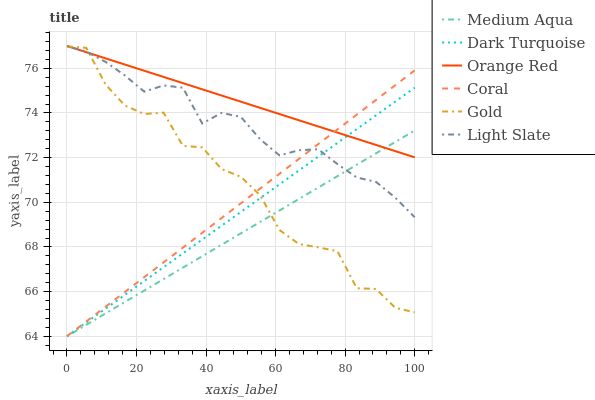Does Medium Aqua have the minimum area under the curve?
Answer yes or no. Yes. Does Orange Red have the maximum area under the curve?
Answer yes or no. Yes. Does Light Slate have the minimum area under the curve?
Answer yes or no. No. Does Light Slate have the maximum area under the curve?
Answer yes or no. No. Is Orange Red the smoothest?
Answer yes or no. Yes. Is Gold the roughest?
Answer yes or no. Yes. Is Light Slate the smoothest?
Answer yes or no. No. Is Light Slate the roughest?
Answer yes or no. No. Does Dark Turquoise have the lowest value?
Answer yes or no. Yes. Does Light Slate have the lowest value?
Answer yes or no. No. Does Orange Red have the highest value?
Answer yes or no. Yes. Does Dark Turquoise have the highest value?
Answer yes or no. No. Does Coral intersect Orange Red?
Answer yes or no. Yes. Is Coral less than Orange Red?
Answer yes or no. No. Is Coral greater than Orange Red?
Answer yes or no. No. 